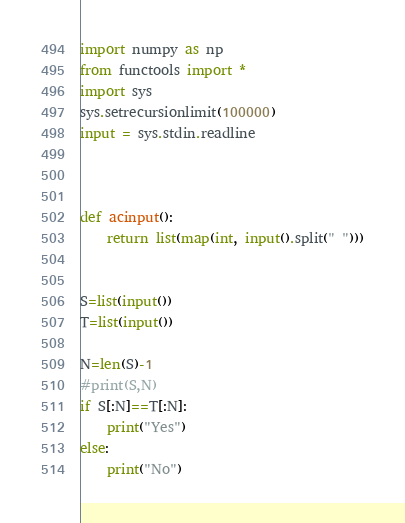<code> <loc_0><loc_0><loc_500><loc_500><_Python_>
import numpy as np
from functools import *
import sys
sys.setrecursionlimit(100000)
input = sys.stdin.readline



def acinput():
    return list(map(int, input().split(" ")))


S=list(input())
T=list(input())

N=len(S)-1
#print(S,N)
if S[:N]==T[:N]:
    print("Yes")
else:
    print("No")


</code> 